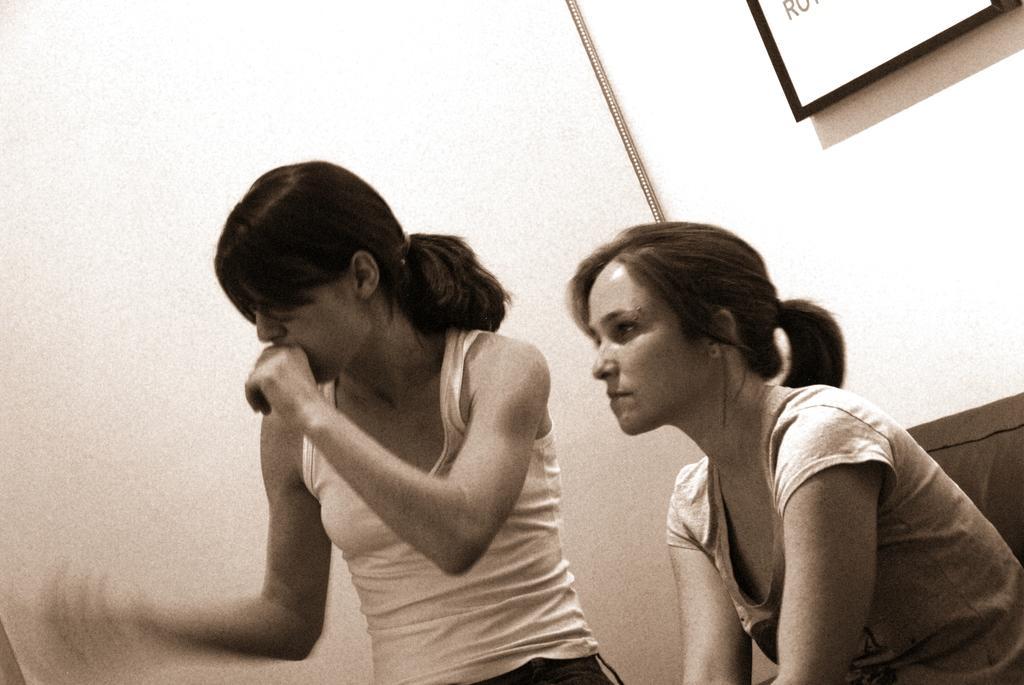Please provide a concise description of this image. In this image we can see two ladies and in the background, we can see the board with some text written on it. 